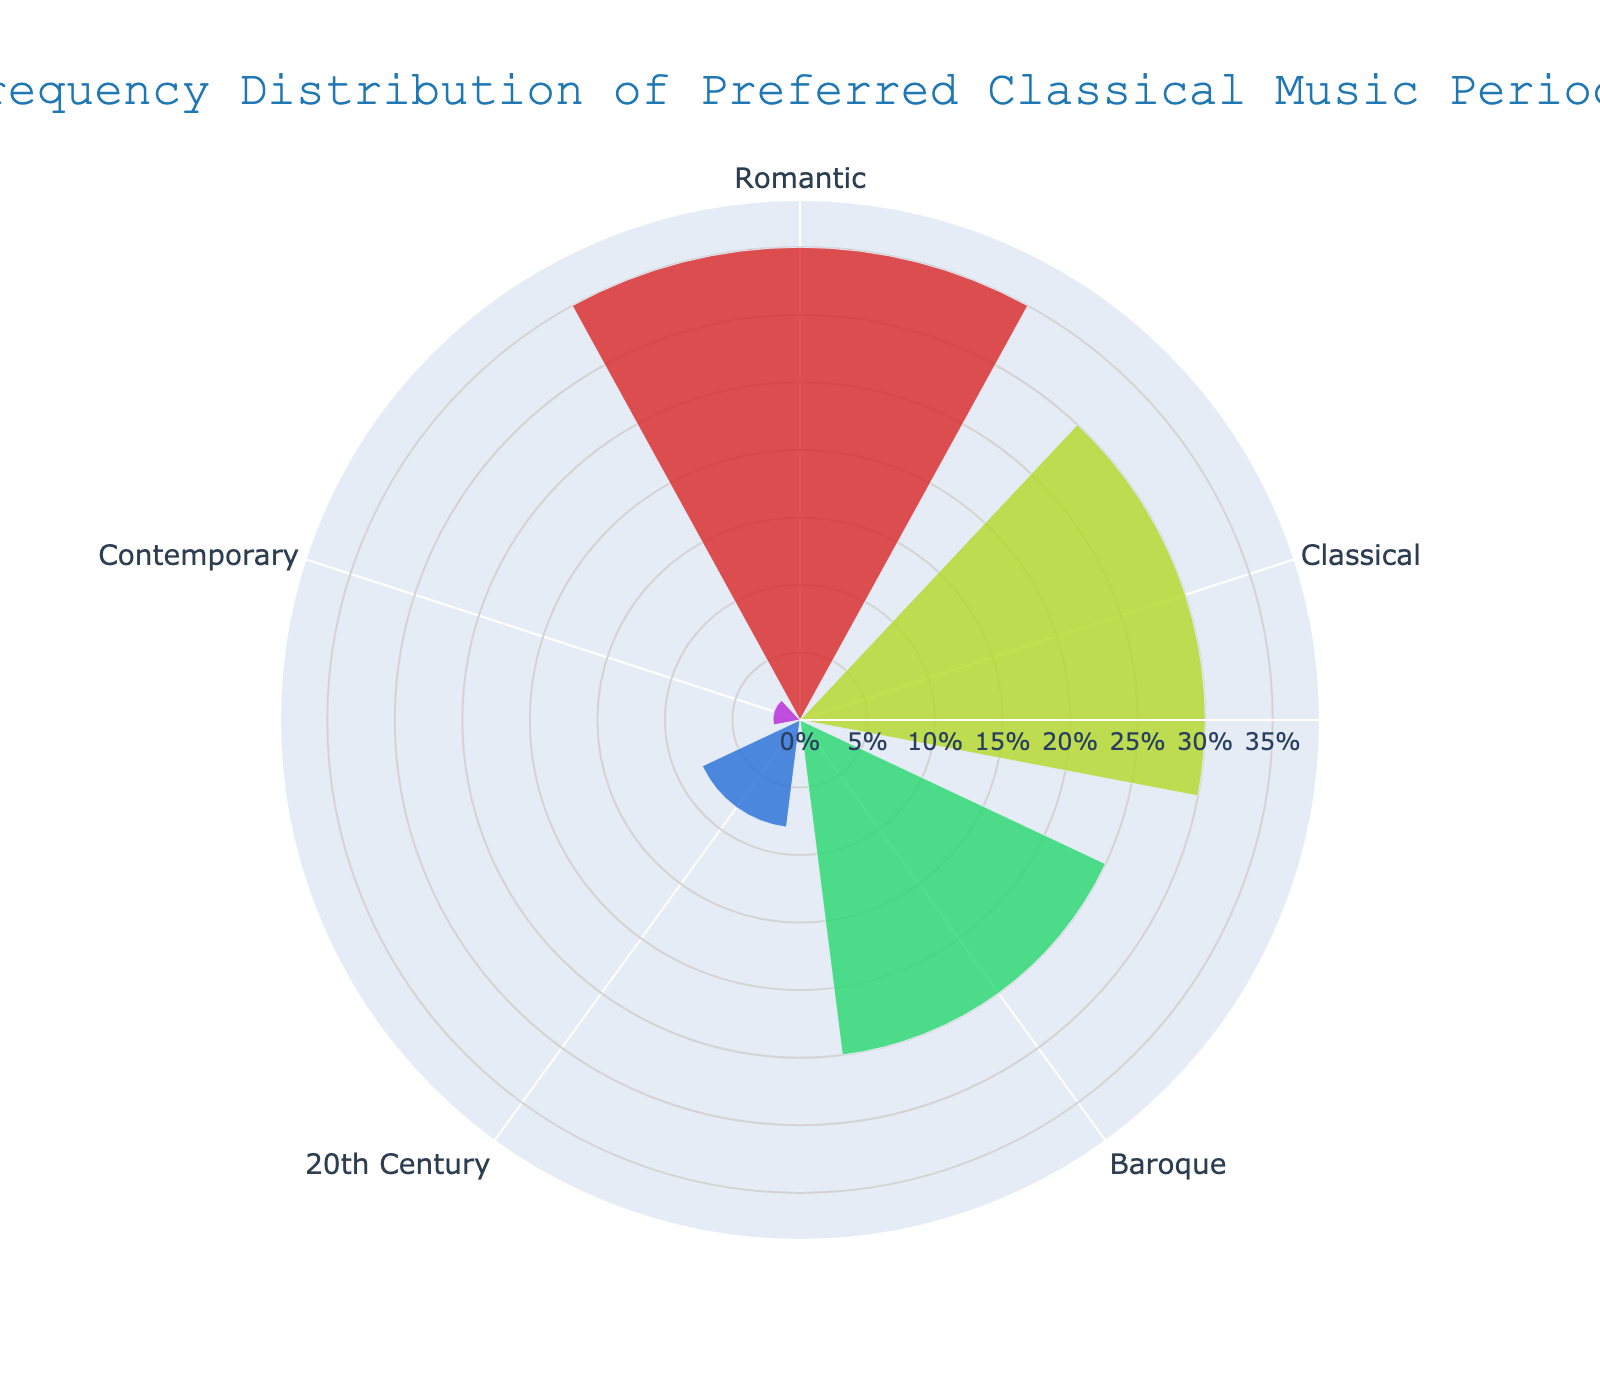What is the most preferred classical music period among patients? The bar representing the Romantic period has the highest percentage on the fan chart, which is 35%. This indicates it is the most preferred period.
Answer: Romantic Which classical music period ranks second in terms of preference? The bar representing the Classical period has the second highest percentage at 30% on the fan chart.
Answer: Classical Combine the percentages for Baroque and Contemporary periods. What is the result? Baroque has 25% and Contemporary has 2%. Adding these together gives 25% + 2% = 27%.
Answer: 27% How much more preferred is the Romantic period compared to the 20th Century period? The Romantic period has 35% while the 20th Century period has 8%. Subtracting these percentages gives 35% - 8% = 27%.
Answer: 27% What is the total percentage of preference for music periods other than Contemporary? Adding the percentages for Baroque (25%), Classical (30%), Romantic (35%), and 20th Century (8%) gives 25% + 30% + 35% + 8% = 98%.
Answer: 98% Compare the preference for Classical and Baroque periods. Which one has a higher percentage and by how much? The Classical period has 30% and the Baroque period has 25%. The difference is 30% - 25% = 5%.
Answer: Classical by 5% Which classical music period is least preferred? The bar representing the Contemporary period has the lowest percentage at 2% on the fan chart.
Answer: Contemporary Find the average percentage preference across all periods. Adding all percentages (25 + 30 + 35 + 8 + 2) gives 100%. Dividing by the number of periods (5) gives an average of 100% / 5 = 20%.
Answer: 20% How many periods have a preference above 20%? Baroque (25%), Classical (30%), and Romantic (35%) each have preferences above 20%. There are three such periods.
Answer: 3 Which period is almost three times more preferred than the Contemporary period? The Contemporary period has 2% preference. The 20th Century period has 8%, which is four times but not mentioned. The closest to three times is Baroque with 25%.
Answer: 20th Century 